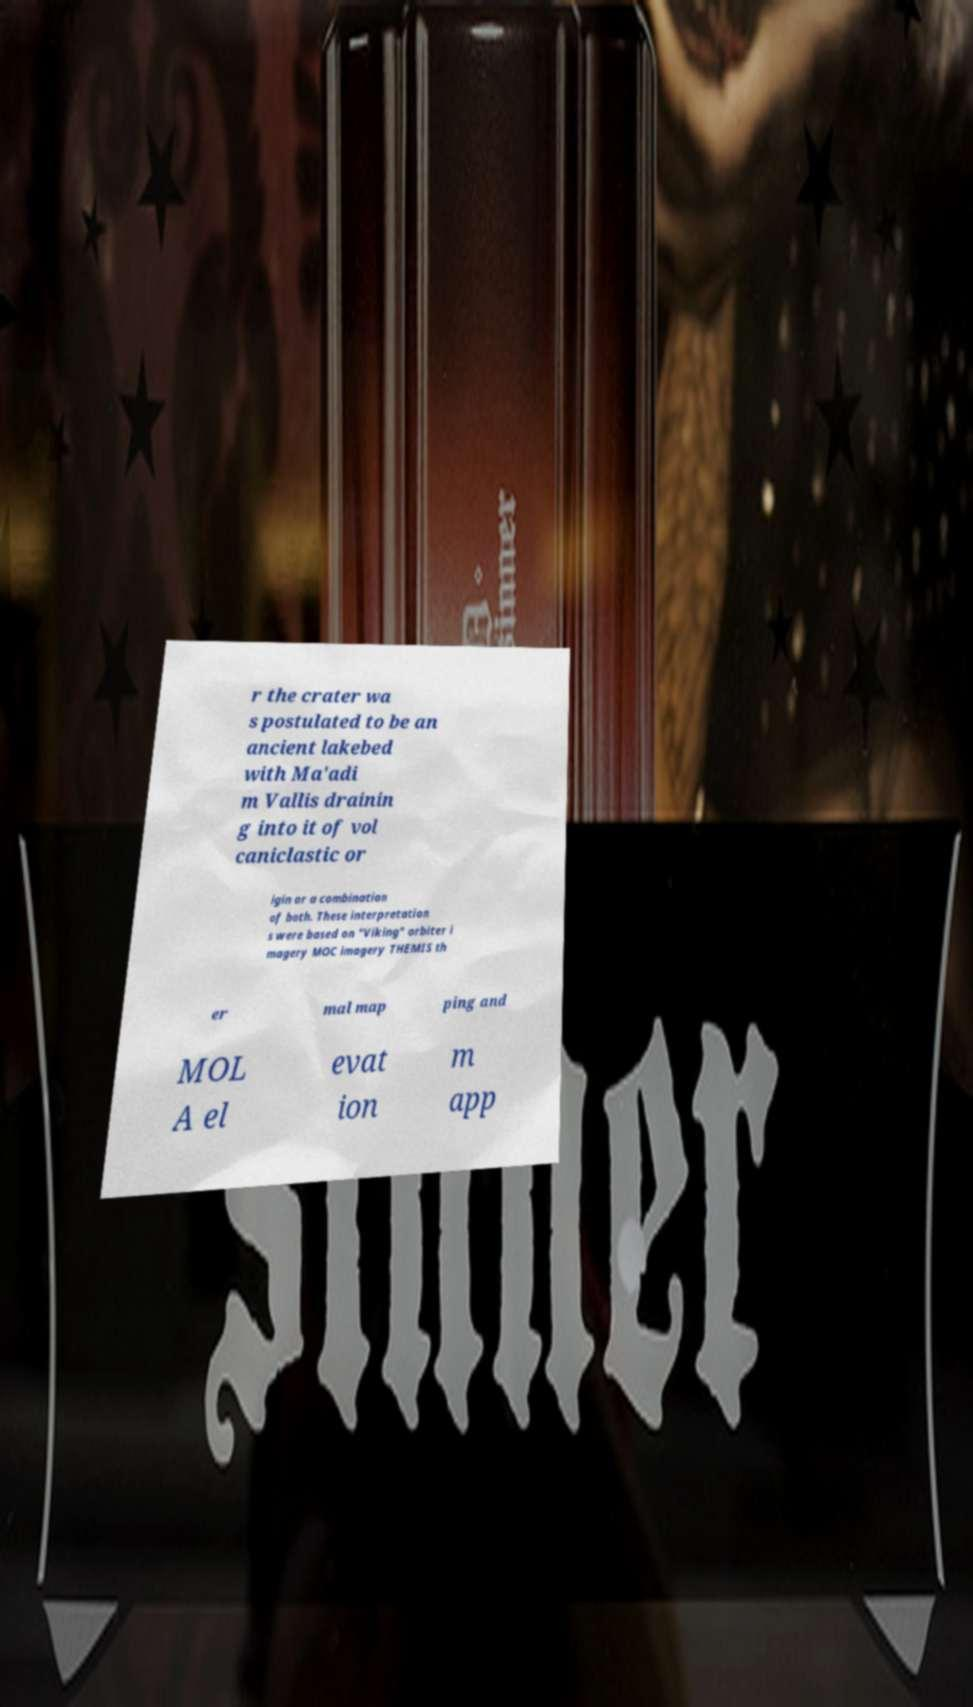What messages or text are displayed in this image? I need them in a readable, typed format. r the crater wa s postulated to be an ancient lakebed with Ma'adi m Vallis drainin g into it of vol caniclastic or igin or a combination of both. These interpretation s were based on "Viking" orbiter i magery MOC imagery THEMIS th er mal map ping and MOL A el evat ion m app 